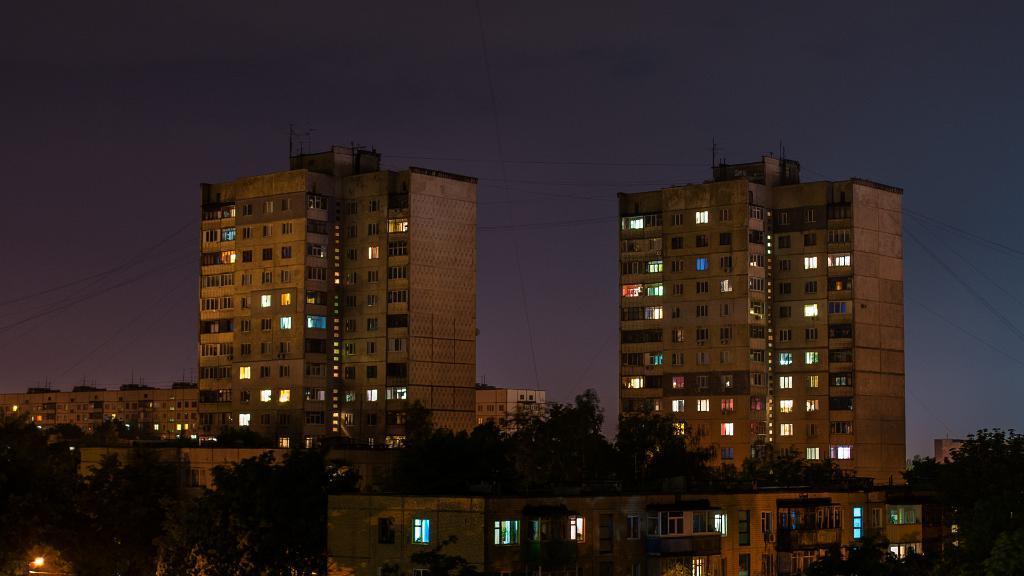Could you give a brief overview of what you see in this image? In this picture we can see buildings, trees and light. In the background of the image we can see the sky. 